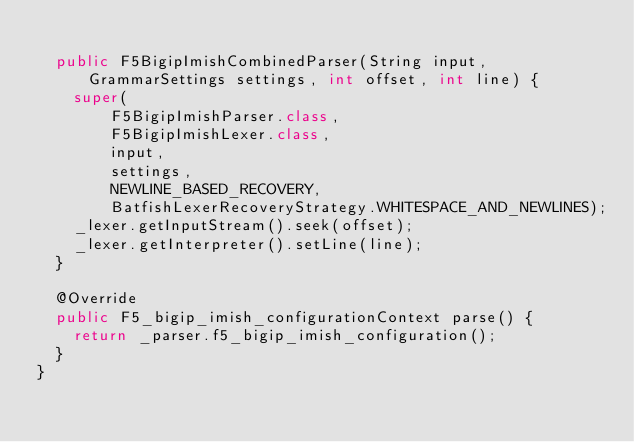<code> <loc_0><loc_0><loc_500><loc_500><_Java_>
  public F5BigipImishCombinedParser(String input, GrammarSettings settings, int offset, int line) {
    super(
        F5BigipImishParser.class,
        F5BigipImishLexer.class,
        input,
        settings,
        NEWLINE_BASED_RECOVERY,
        BatfishLexerRecoveryStrategy.WHITESPACE_AND_NEWLINES);
    _lexer.getInputStream().seek(offset);
    _lexer.getInterpreter().setLine(line);
  }

  @Override
  public F5_bigip_imish_configurationContext parse() {
    return _parser.f5_bigip_imish_configuration();
  }
}
</code> 